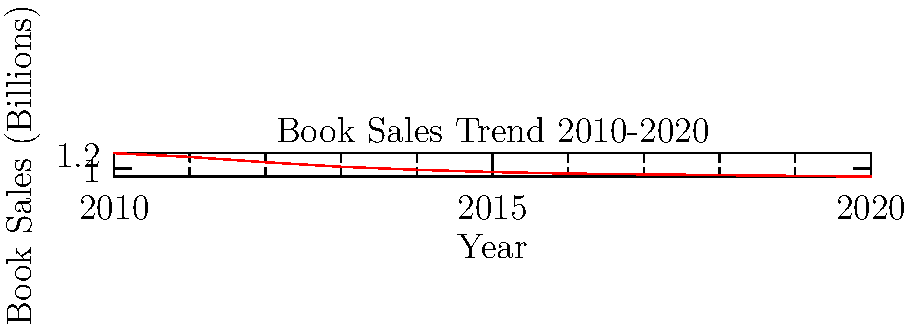Based on the line graph showing book sales trends from 2010 to 2020, what can be inferred about the financial stability of pursuing a writing career? Consider both the overall trend and any potential opportunities or challenges this data might present for aspiring authors. To analyze the financial stability of pursuing a writing career based on this graph, let's follow these steps:

1. Observe the overall trend:
   The graph shows a clear downward trend in book sales from 2010 to 2020.

2. Quantify the decline:
   In 2010, book sales were approximately $1.20 billion.
   By 2020, they had decreased to about $0.89 billion.
   This represents a decline of about 25.8% over the decade.

3. Assess the rate of decline:
   The steepest decline appears to be between 2010 and 2014.
   From 2014 onwards, the decline slows down but continues.

4. Consider the implications for writers:
   a. Decreased overall market size means potentially lower total earnings for authors.
   b. Increased competition for a shrinking market may make it harder to secure publishing deals or achieve significant sales.

5. Identify potential opportunities:
   a. The slowing rate of decline in recent years might indicate a stabilizing market.
   b. Digital formats and self-publishing, not reflected in this graph, may offer new avenues for writers.

6. Evaluate financial stability:
   Given the consistent downward trend, pursuing a writing career solely based on traditional book sales appears increasingly financially unstable.

7. Consider diversification:
   Writers may need to explore multiple income streams (e.g., e-books, audiobooks, speaking engagements) to achieve financial stability.
Answer: Declining book sales trend suggests decreased financial stability for writing careers, necessitating diversification of income sources. 